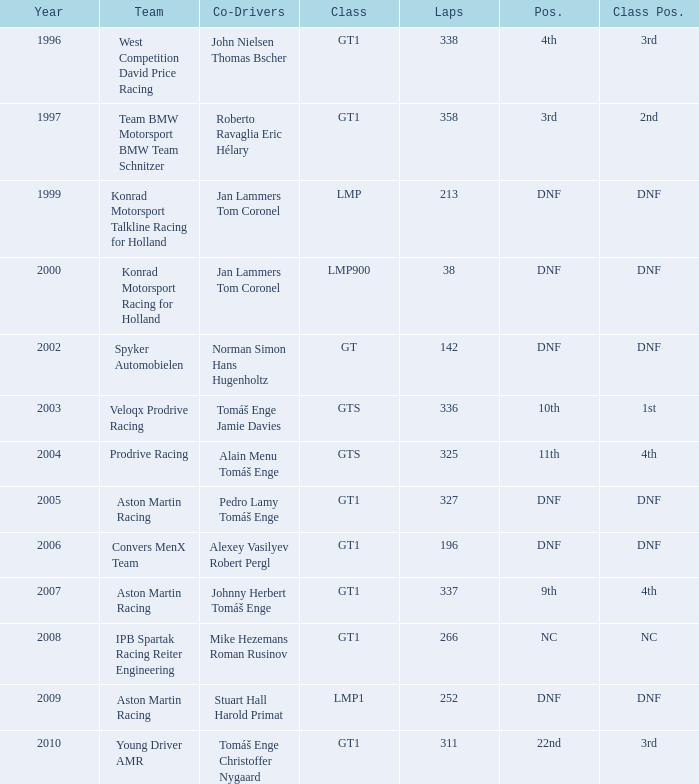Which team finished 3rd in class with 337 laps before 2008? West Competition David Price Racing. 